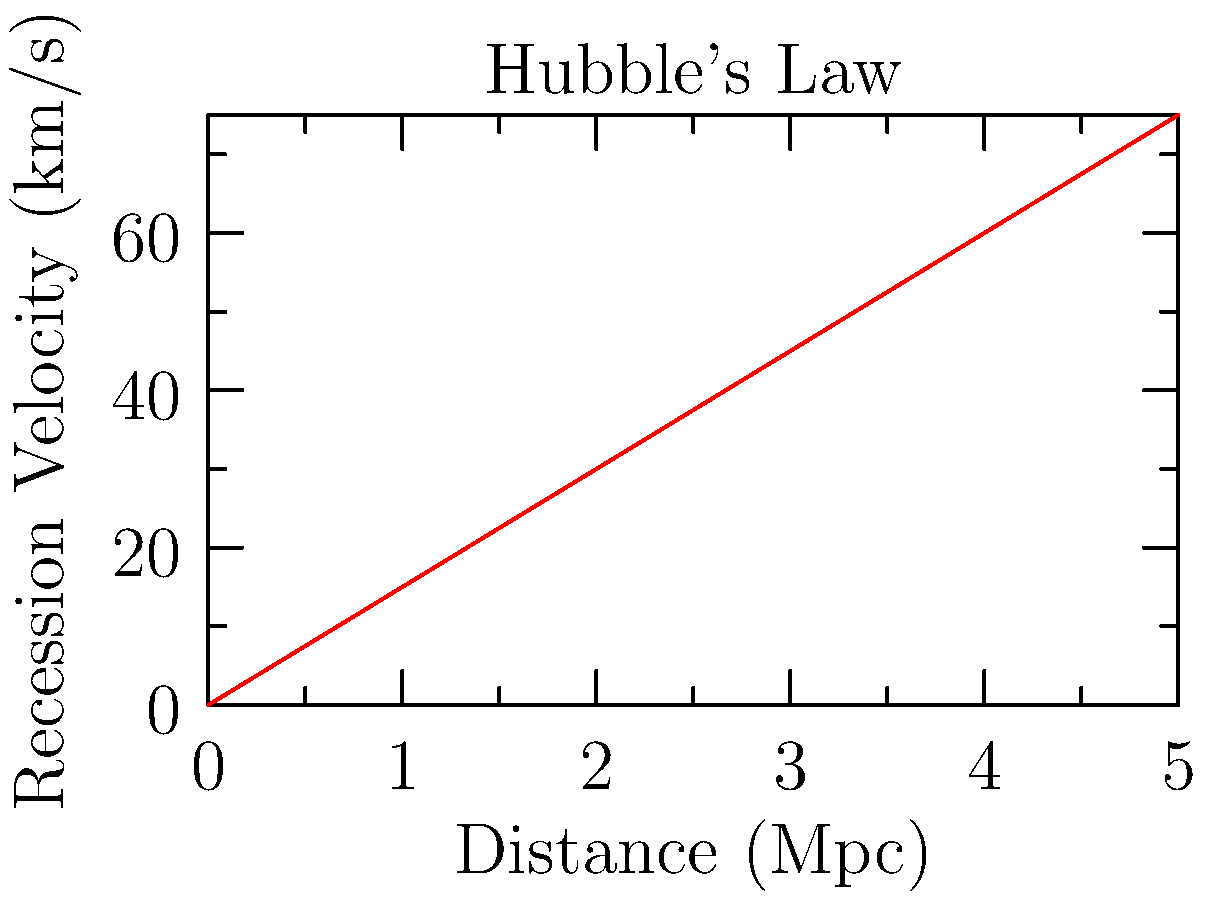Based on the graph showing the relationship between galactic recession velocities and distances, estimate the age of the universe. Assume the Hubble constant $H_0$ is approximately the slope of the line, and use the approximation that the age of the universe is roughly $\frac{1}{H_0}$. Give your answer in billions of years. To estimate the age of the universe using this graph:

1. Calculate the slope of the line (Hubble constant $H_0$):
   $H_0 = \frac{\text{change in y}}{\text{change in x}} = \frac{75 \text{ km/s}}{5 \text{ Mpc}} = 15 \text{ km/s/Mpc}$

2. Convert units:
   $15 \frac{\text{km/s}}{\text{Mpc}} = 15 \frac{\text{km/s}}{\text{Mpc}} \times \frac{3.086 \times 10^{19} \text{ km}}{\text{Mpc}} \times \frac{1}{\text{3.156} \times 10^7 \text{ s/year}} = 4.85 \times 10^{-18} \text{ year}^{-1}$

3. Estimate the age of the universe:
   $\text{Age} \approx \frac{1}{H_0} = \frac{1}{4.85 \times 10^{-18} \text{ year}^{-1}} = 2.06 \times 10^{17} \text{ years}$

4. Convert to billions of years:
   $2.06 \times 10^{17} \text{ years} \times \frac{1 \text{ billion}}{10^9 \text{ years}} = 206 \text{ billion years}$

This estimate is higher than the currently accepted age of the universe (about 13.8 billion years) due to the simplified nature of the calculation and the approximate data used in the graph.
Answer: 206 billion years 